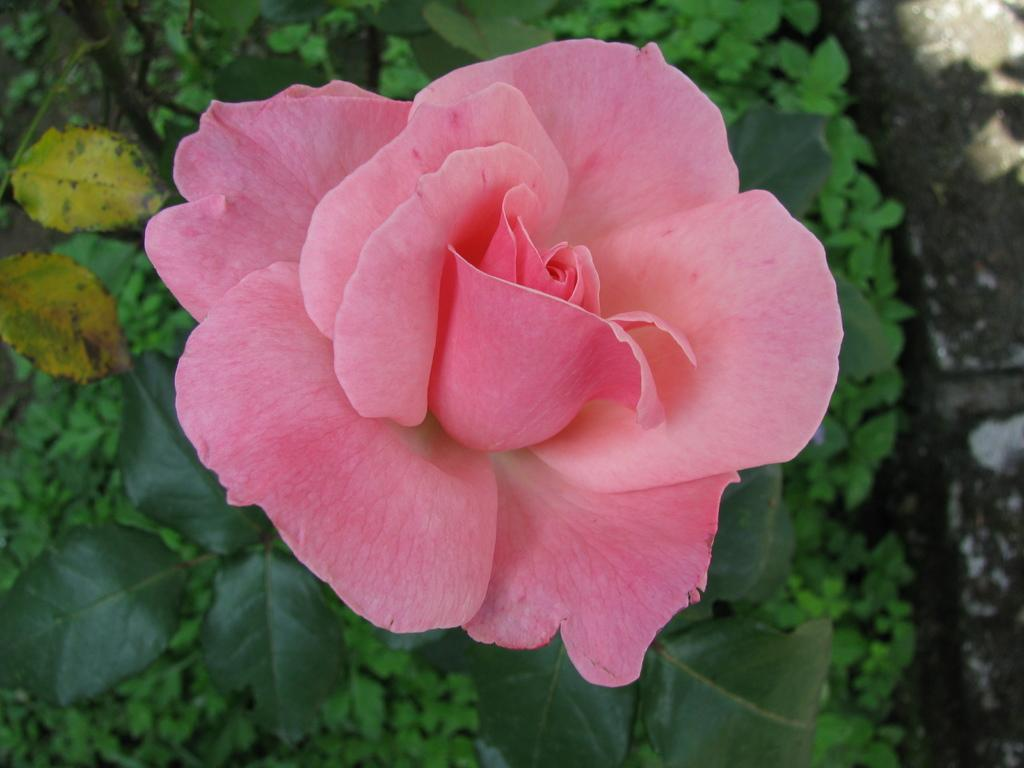What type of flower is in the image? There is a rose in the image. What color is the rose in the image? The rose is pink in color. Are there any other parts of the plant visible in the image? Yes, there are leaves associated with the rose. What type of rod can be seen being used by the achiever in the image? There is no achiever or rod present in the image; it features a pink rose with leaves. What word is written on the petals of the rose in the image? There are no words written on the petals of the rose in the image. 